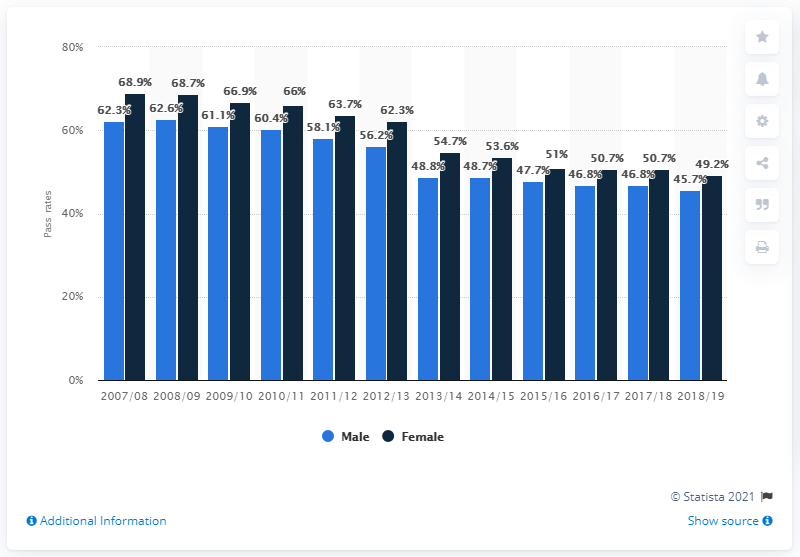Highlight a few significant elements in this photo. In March 2019, the pass rate for women in the driving theory test in the UK was 49.2%. 